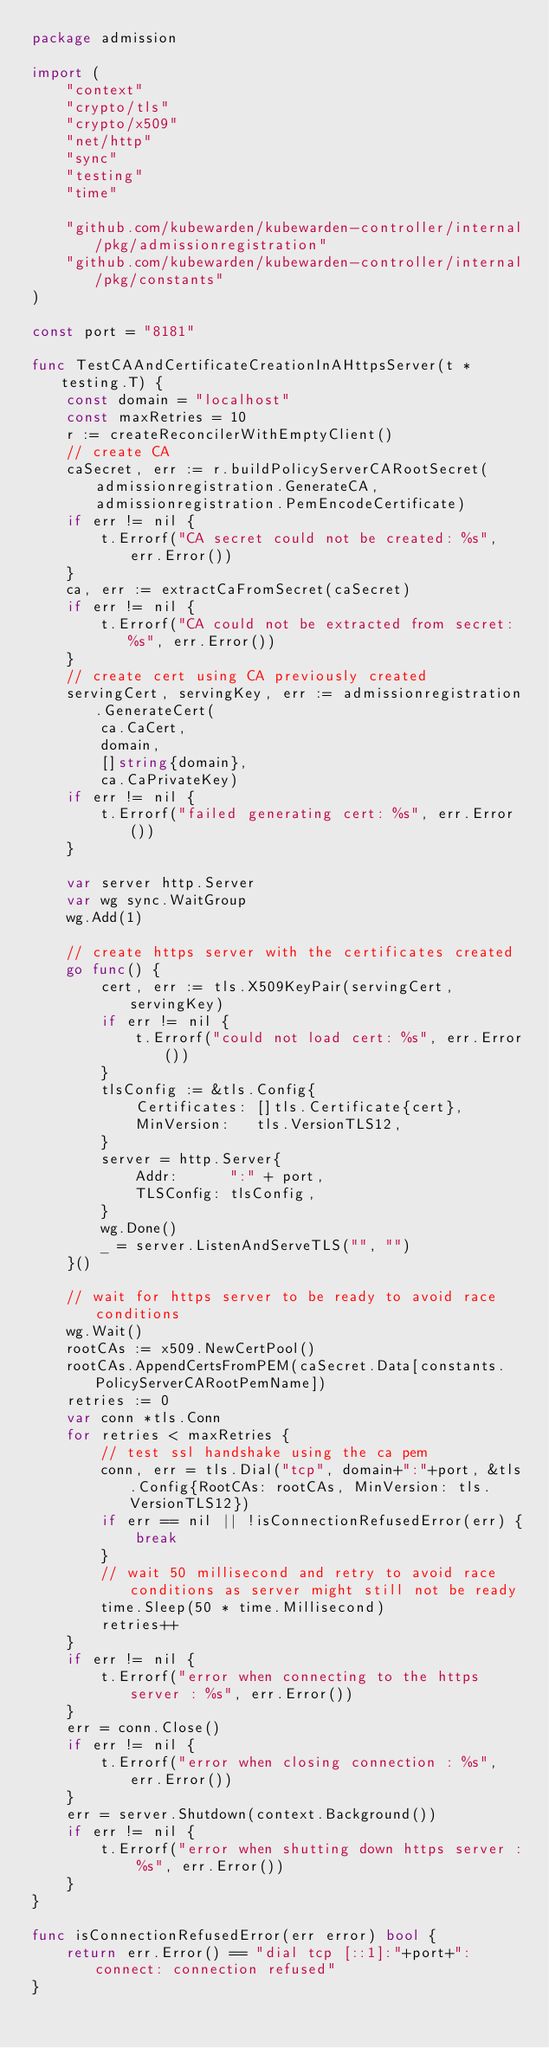<code> <loc_0><loc_0><loc_500><loc_500><_Go_>package admission

import (
	"context"
	"crypto/tls"
	"crypto/x509"
	"net/http"
	"sync"
	"testing"
	"time"

	"github.com/kubewarden/kubewarden-controller/internal/pkg/admissionregistration"
	"github.com/kubewarden/kubewarden-controller/internal/pkg/constants"
)

const port = "8181"

func TestCAAndCertificateCreationInAHttpsServer(t *testing.T) {
	const domain = "localhost"
	const maxRetries = 10
	r := createReconcilerWithEmptyClient()
	// create CA
	caSecret, err := r.buildPolicyServerCARootSecret(admissionregistration.GenerateCA, admissionregistration.PemEncodeCertificate)
	if err != nil {
		t.Errorf("CA secret could not be created: %s", err.Error())
	}
	ca, err := extractCaFromSecret(caSecret)
	if err != nil {
		t.Errorf("CA could not be extracted from secret: %s", err.Error())
	}
	// create cert using CA previously created
	servingCert, servingKey, err := admissionregistration.GenerateCert(
		ca.CaCert,
		domain,
		[]string{domain},
		ca.CaPrivateKey)
	if err != nil {
		t.Errorf("failed generating cert: %s", err.Error())
	}

	var server http.Server
	var wg sync.WaitGroup
	wg.Add(1)

	// create https server with the certificates created
	go func() {
		cert, err := tls.X509KeyPair(servingCert, servingKey)
		if err != nil {
			t.Errorf("could not load cert: %s", err.Error())
		}
		tlsConfig := &tls.Config{
			Certificates: []tls.Certificate{cert},
			MinVersion:   tls.VersionTLS12,
		}
		server = http.Server{
			Addr:      ":" + port,
			TLSConfig: tlsConfig,
		}
		wg.Done()
		_ = server.ListenAndServeTLS("", "")
	}()

	// wait for https server to be ready to avoid race conditions
	wg.Wait()
	rootCAs := x509.NewCertPool()
	rootCAs.AppendCertsFromPEM(caSecret.Data[constants.PolicyServerCARootPemName])
	retries := 0
	var conn *tls.Conn
	for retries < maxRetries {
		// test ssl handshake using the ca pem
		conn, err = tls.Dial("tcp", domain+":"+port, &tls.Config{RootCAs: rootCAs, MinVersion: tls.VersionTLS12})
		if err == nil || !isConnectionRefusedError(err) {
			break
		}
		// wait 50 millisecond and retry to avoid race conditions as server might still not be ready
		time.Sleep(50 * time.Millisecond)
		retries++
	}
	if err != nil {
		t.Errorf("error when connecting to the https server : %s", err.Error())
	}
	err = conn.Close()
	if err != nil {
		t.Errorf("error when closing connection : %s", err.Error())
	}
	err = server.Shutdown(context.Background())
	if err != nil {
		t.Errorf("error when shutting down https server : %s", err.Error())
	}
}

func isConnectionRefusedError(err error) bool {
	return err.Error() == "dial tcp [::1]:"+port+": connect: connection refused"
}
</code> 